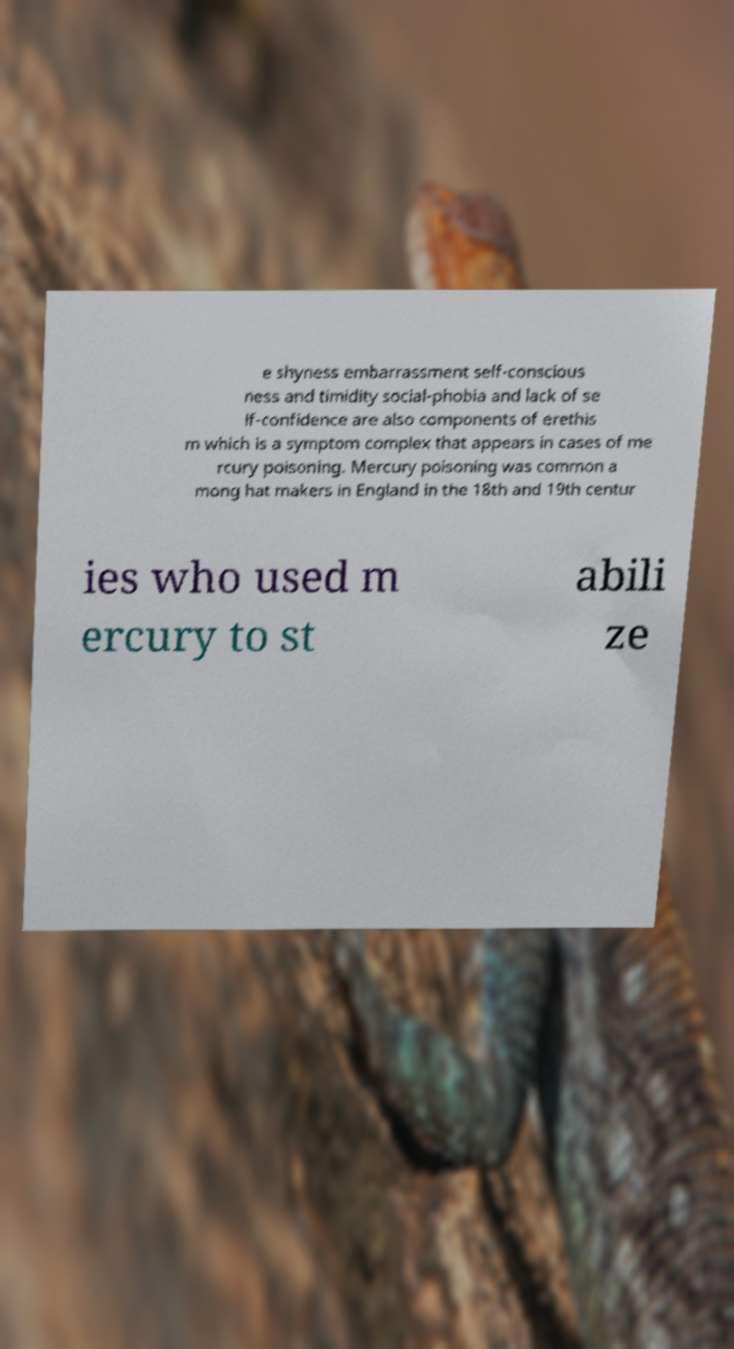Can you accurately transcribe the text from the provided image for me? e shyness embarrassment self-conscious ness and timidity social-phobia and lack of se lf-confidence are also components of erethis m which is a symptom complex that appears in cases of me rcury poisoning. Mercury poisoning was common a mong hat makers in England in the 18th and 19th centur ies who used m ercury to st abili ze 